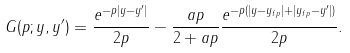<formula> <loc_0><loc_0><loc_500><loc_500>\ G ( p ; y , y ^ { \prime } ) = \frac { e ^ { - p | y - y ^ { \prime } | } } { 2 p } - \frac { a p } { 2 + a p } \frac { e ^ { - p ( | y - y _ { f p } | + | y _ { f p } - y ^ { \prime } | ) } } { 2 p } .</formula> 